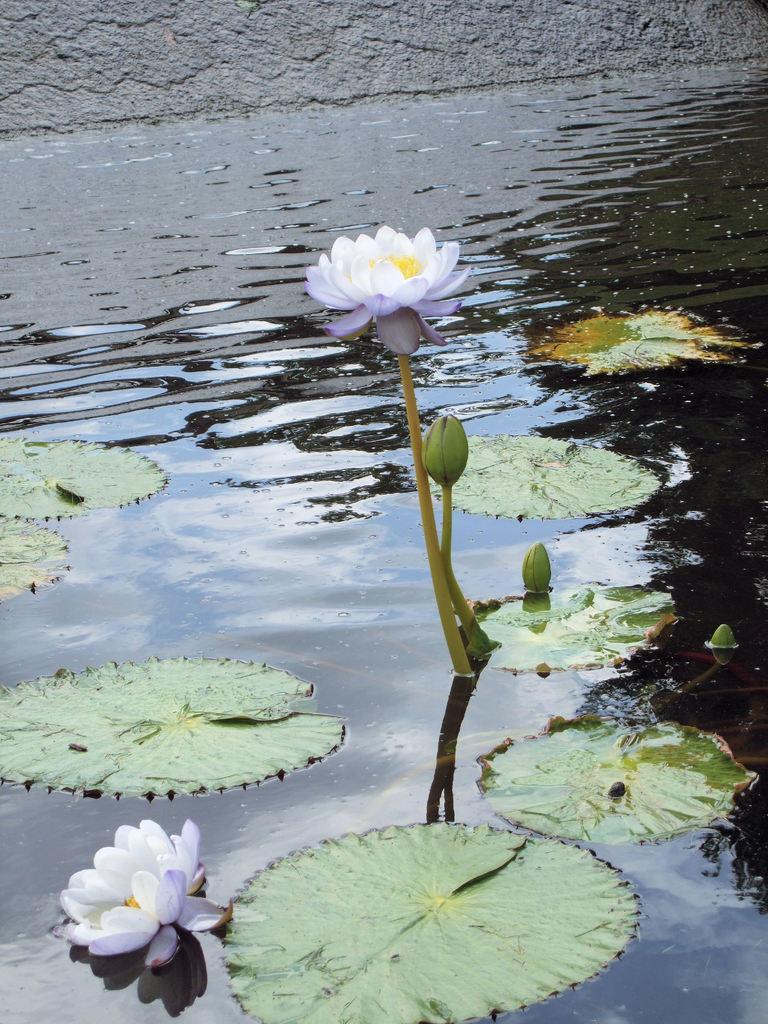Please provide a concise description of this image. In the picture I can see flowers in the water and leaves floating on the water. These flowers are white in color. 